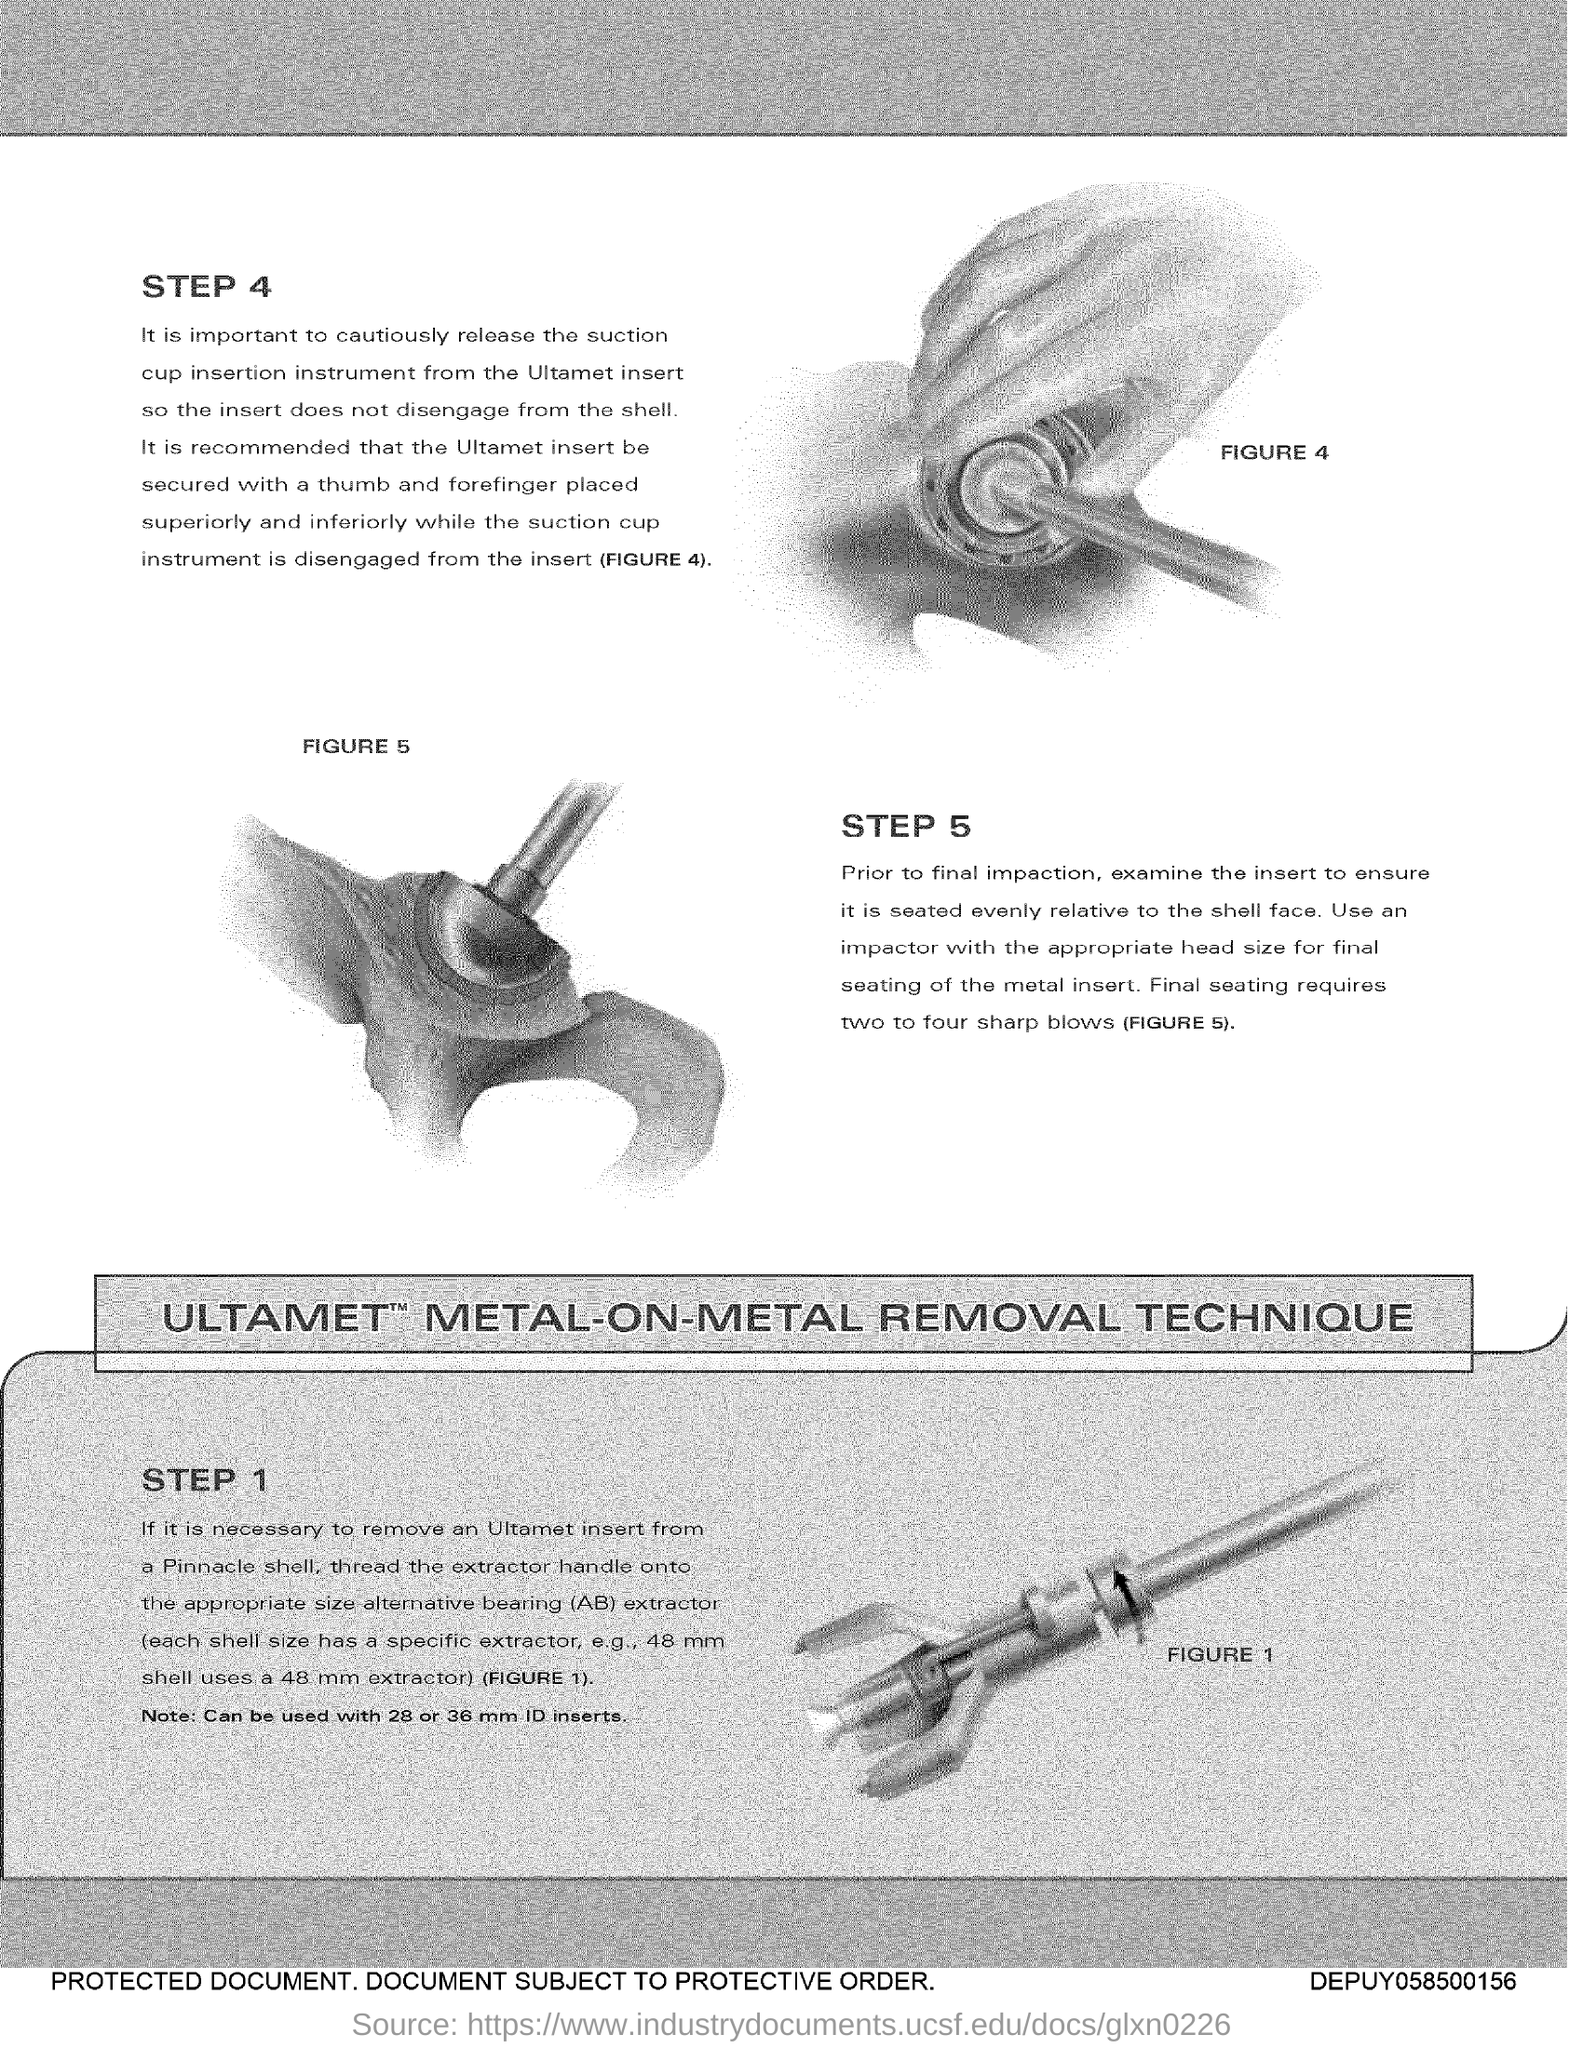What is the text written above the left side figure?
Offer a terse response. Figure 5. 